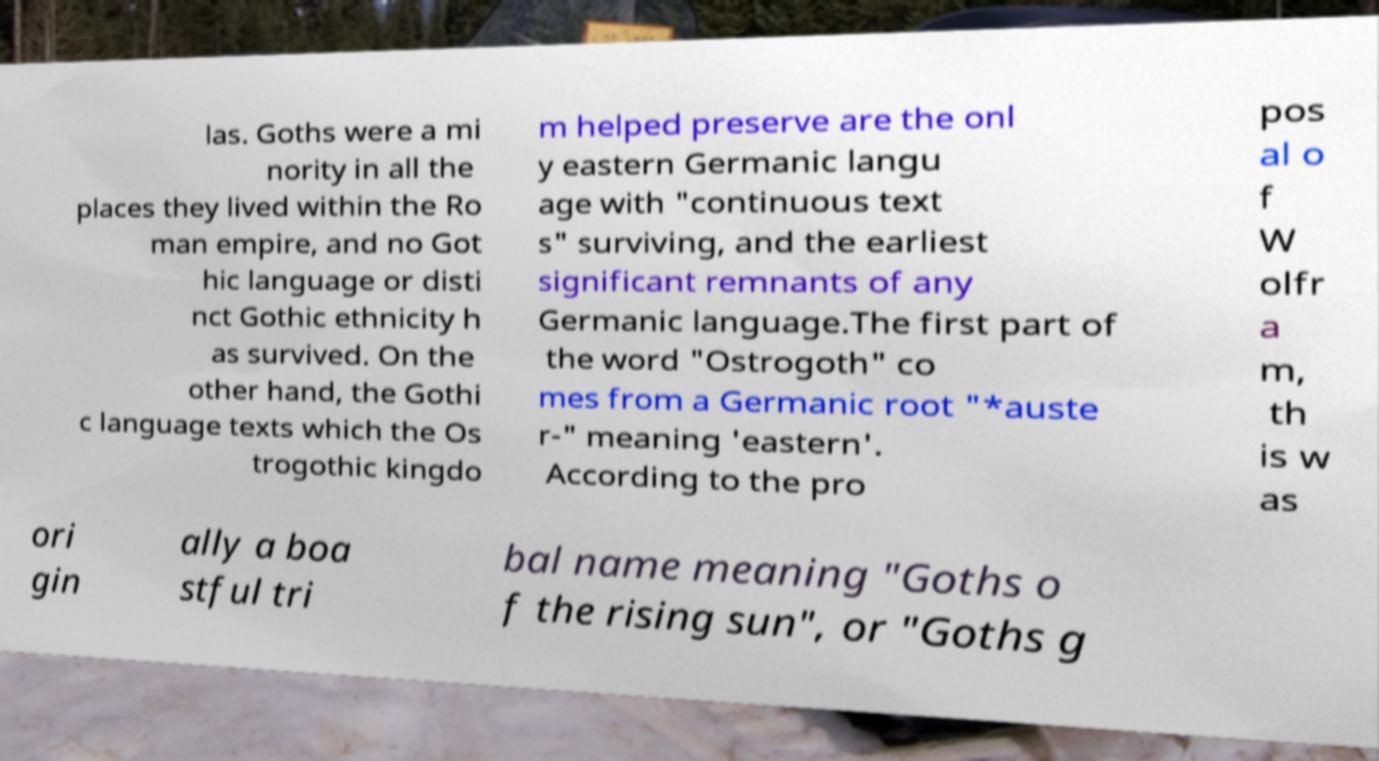Can you accurately transcribe the text from the provided image for me? las. Goths were a mi nority in all the places they lived within the Ro man empire, and no Got hic language or disti nct Gothic ethnicity h as survived. On the other hand, the Gothi c language texts which the Os trogothic kingdo m helped preserve are the onl y eastern Germanic langu age with "continuous text s" surviving, and the earliest significant remnants of any Germanic language.The first part of the word "Ostrogoth" co mes from a Germanic root "*auste r-" meaning 'eastern'. According to the pro pos al o f W olfr a m, th is w as ori gin ally a boa stful tri bal name meaning "Goths o f the rising sun", or "Goths g 